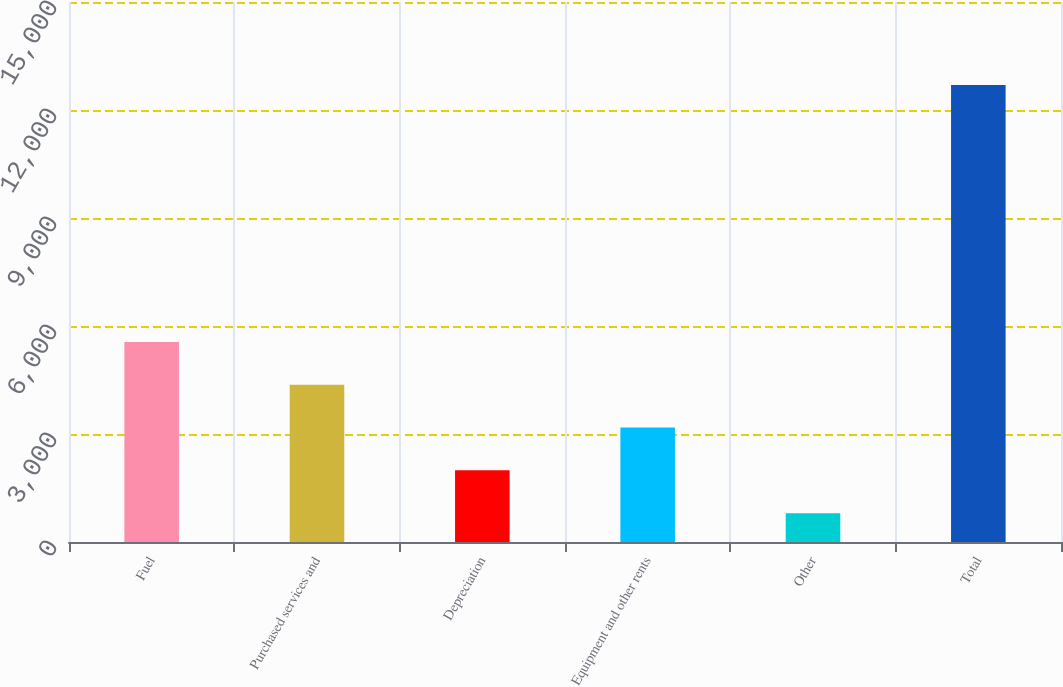<chart> <loc_0><loc_0><loc_500><loc_500><bar_chart><fcel>Fuel<fcel>Purchased services and<fcel>Depreciation<fcel>Equipment and other rents<fcel>Other<fcel>Total<nl><fcel>5558.8<fcel>4369.6<fcel>1991.2<fcel>3180.4<fcel>802<fcel>12694<nl></chart> 